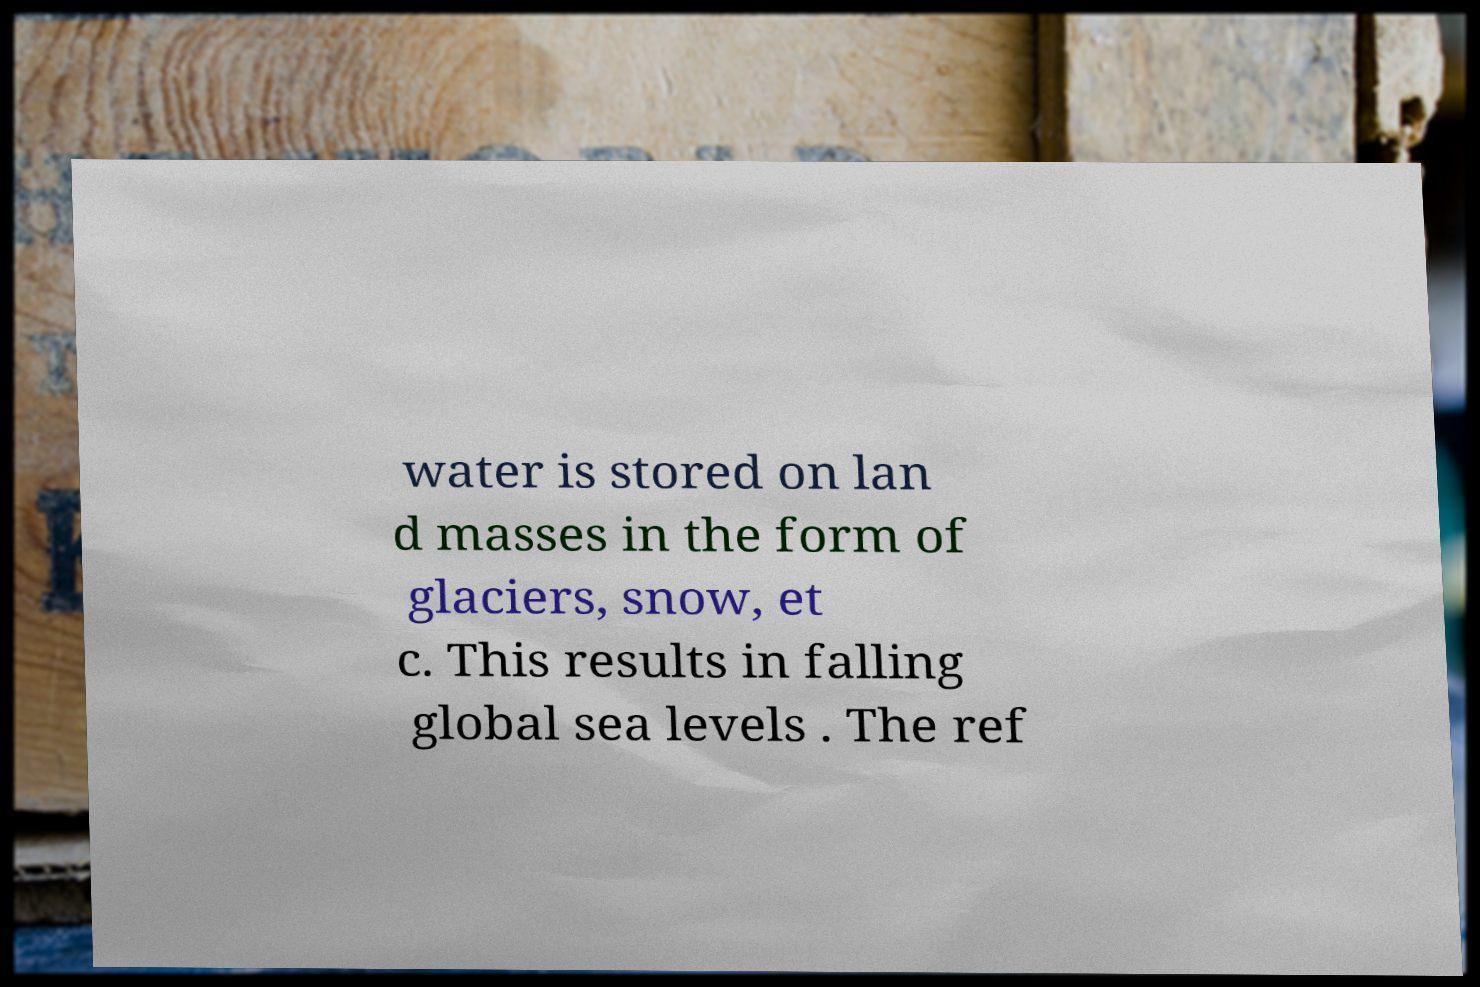There's text embedded in this image that I need extracted. Can you transcribe it verbatim? water is stored on lan d masses in the form of glaciers, snow, et c. This results in falling global sea levels . The ref 